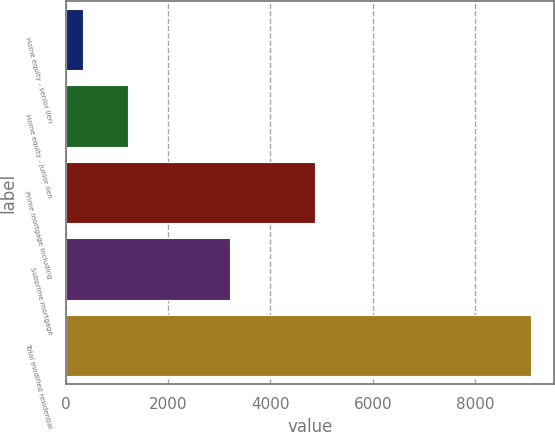Convert chart to OTSL. <chart><loc_0><loc_0><loc_500><loc_500><bar_chart><fcel>Home equity - senior lien<fcel>Home equity - junior lien<fcel>Prime mortgage including<fcel>Subprime mortgage<fcel>Total modified residential<nl><fcel>335<fcel>1210.3<fcel>4877<fcel>3219<fcel>9088<nl></chart> 